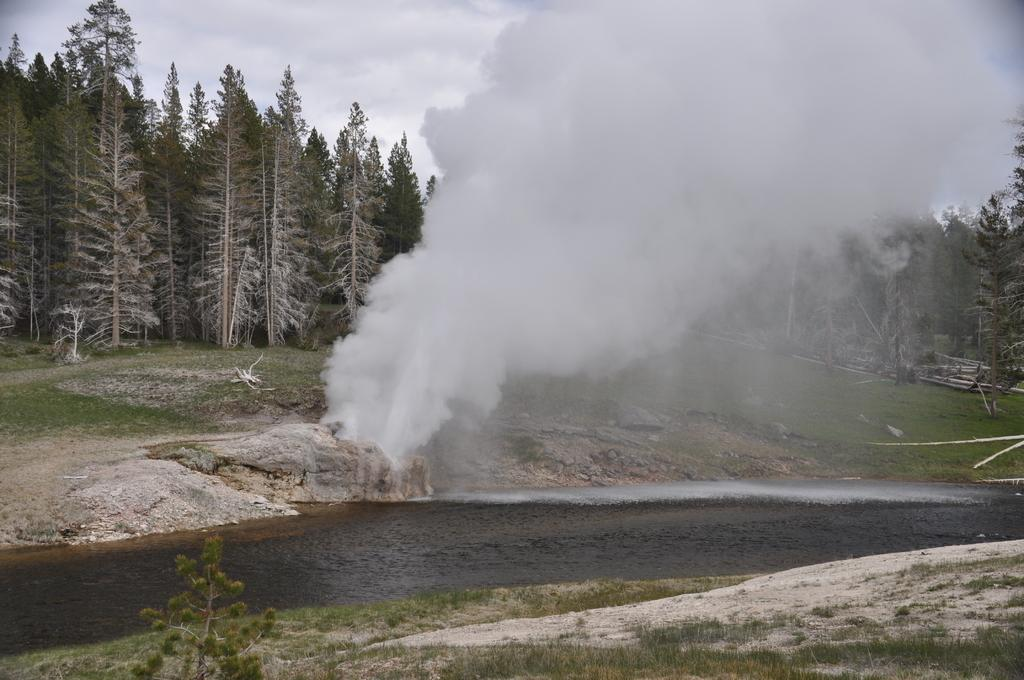What is present at the bottom of the image? There is water at the bottom of the image. What can be seen in the background of the image? There are trees in the background of the image. What is visible in the center of the image? There is smoke in the center of the image. How many bikes are parked near the trees in the image? There are no bikes present in the image. What type of control is being exerted over the smoke in the image? There is no indication of control being exerted over the smoke in the image. Can you see a rat in the water at the bottom of the image? There is no rat present in the image. 